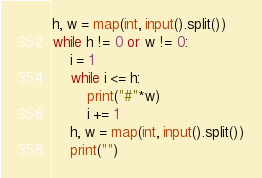<code> <loc_0><loc_0><loc_500><loc_500><_Python_>h, w = map(int, input().split())
while h != 0 or w != 0:
    i = 1
    while i <= h:
        print("#"*w)
        i += 1
    h, w = map(int, input().split())
    print("")

</code> 